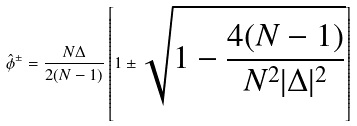<formula> <loc_0><loc_0><loc_500><loc_500>\hat { \phi } ^ { \pm } = \frac { N \Delta } { 2 ( N - 1 ) } \left [ 1 \pm \sqrt { 1 - \frac { 4 ( N - 1 ) } { N ^ { 2 } | \Delta | ^ { 2 } } } \right ]</formula> 